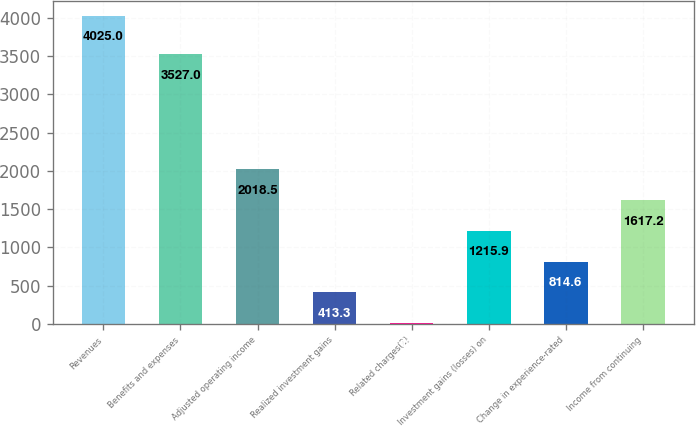<chart> <loc_0><loc_0><loc_500><loc_500><bar_chart><fcel>Revenues<fcel>Benefits and expenses<fcel>Adjusted operating income<fcel>Realized investment gains<fcel>Related charges(2)<fcel>Investment gains (losses) on<fcel>Change in experience-rated<fcel>Income from continuing<nl><fcel>4025<fcel>3527<fcel>2018.5<fcel>413.3<fcel>12<fcel>1215.9<fcel>814.6<fcel>1617.2<nl></chart> 